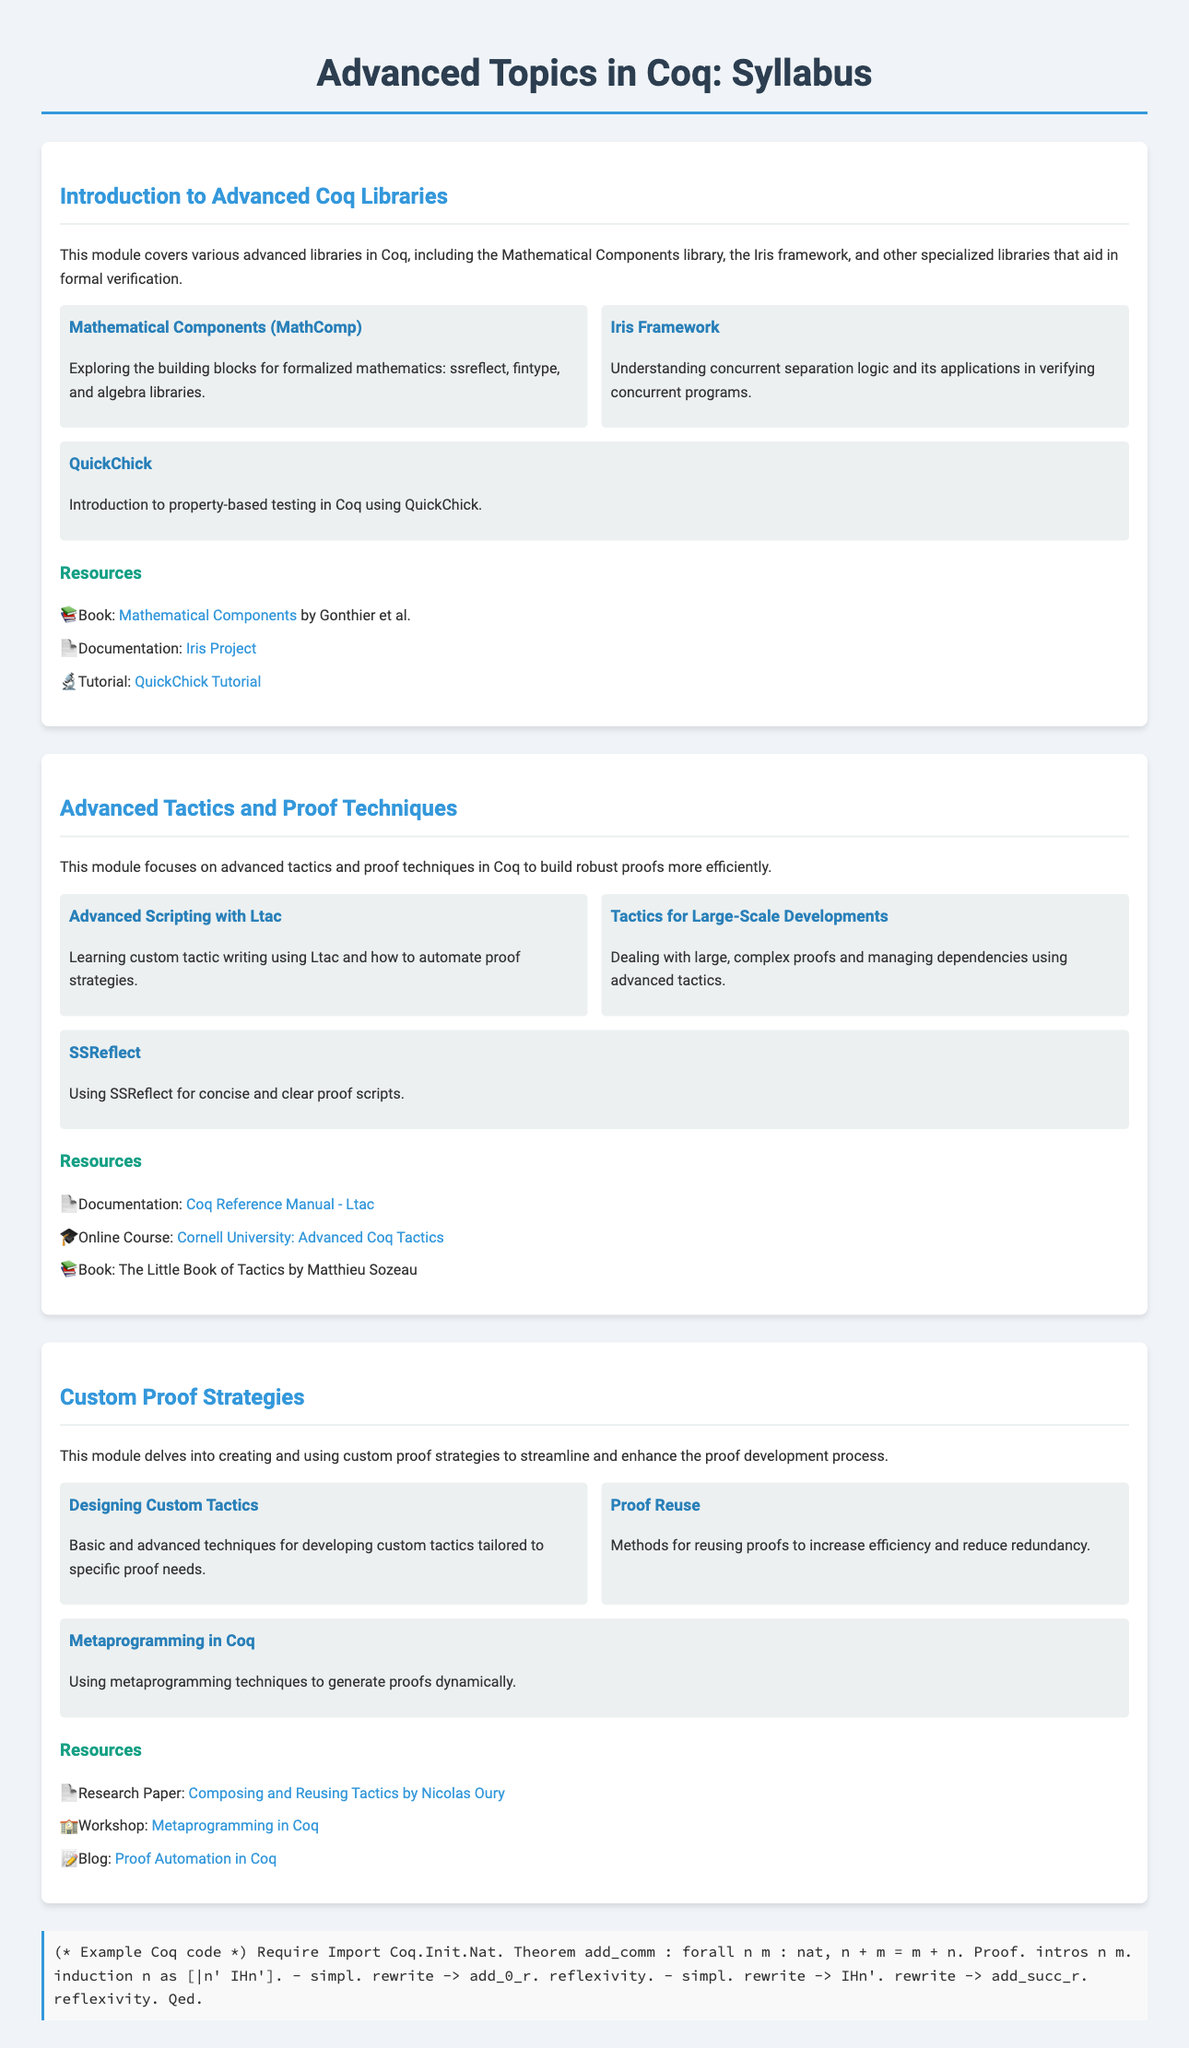What is the title of the syllabus? The title is mentioned at the top of the document and provides a clear indication of the content covered within, which is "Advanced Topics in Coq: Syllabus".
Answer: Advanced Topics in Coq: Syllabus What are the modules covered in the syllabus? The modules are clearly stated in their respective sections of the document, detailing the content and topics discussed, including "Introduction to Advanced Coq Libraries", "Advanced Tactics and Proof Techniques", and "Custom Proof Strategies".
Answer: Introduction to Advanced Coq Libraries, Advanced Tactics and Proof Techniques, Custom Proof Strategies Which library is explored for concurrent verification? The document specifies that the Iris framework is associated with verifying concurrent programs within the advanced Coq libraries.
Answer: Iris framework What is the focus of the module on Custom Proof Strategies? The document outlines that this module focuses specifically on creating and using custom proof strategies to improve the proof development process.
Answer: Creating and using custom proof strategies How many topics are included in the Advanced Tactics and Proof Techniques module? The number of topics can be counted from the content describing that module, which includes three distinct topics.
Answer: Three topics What is one of the resources listed for the Mathematical Components library? Resources are provided for further study and reference, one being a book authored by Gonthier et al. about the Mathematical Components.
Answer: Mathematical Components by Gonthier et al What is the method introduced for property-based testing? The document describes QuickChick as the method for property-based testing within Coq which is introduced in the syllabus.
Answer: QuickChick What does SSReflect help with in terms of proof scripts? The syllabus states that SSReflect aids in producing concise and clear proof scripts, enhancing clarity in the proof process.
Answer: Concise and clear proof scripts 